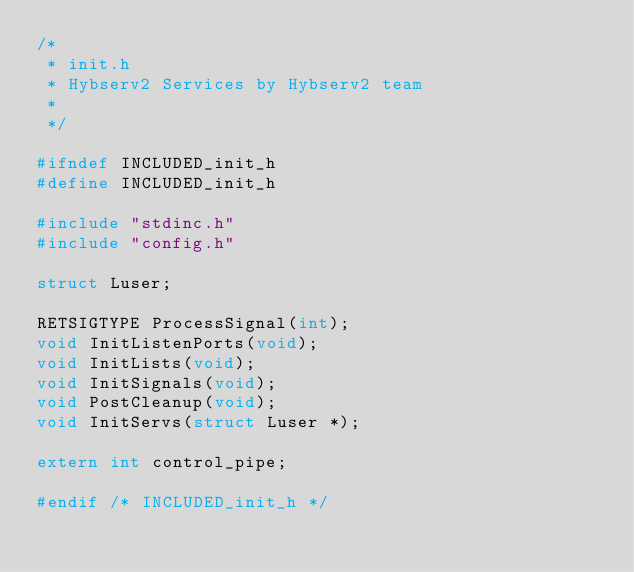Convert code to text. <code><loc_0><loc_0><loc_500><loc_500><_C_>/*
 * init.h
 * Hybserv2 Services by Hybserv2 team
 *
 */

#ifndef INCLUDED_init_h
#define INCLUDED_init_h

#include "stdinc.h"
#include "config.h"

struct Luser;

RETSIGTYPE ProcessSignal(int);
void InitListenPorts(void);
void InitLists(void);
void InitSignals(void);
void PostCleanup(void);
void InitServs(struct Luser *);

extern int control_pipe;

#endif /* INCLUDED_init_h */
</code> 